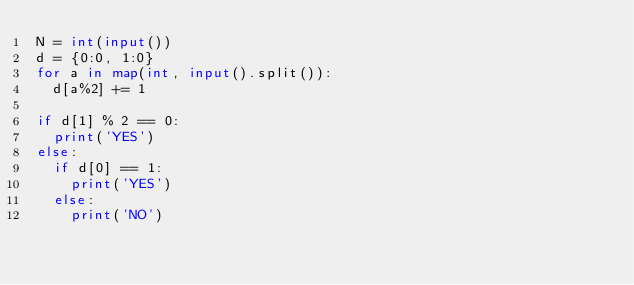Convert code to text. <code><loc_0><loc_0><loc_500><loc_500><_Python_>N = int(input())
d = {0:0, 1:0}
for a in map(int, input().split()):
  d[a%2] += 1

if d[1] % 2 == 0:
  print('YES')
else:
  if d[0] == 1:
    print('YES')
  else:
    print('NO')</code> 